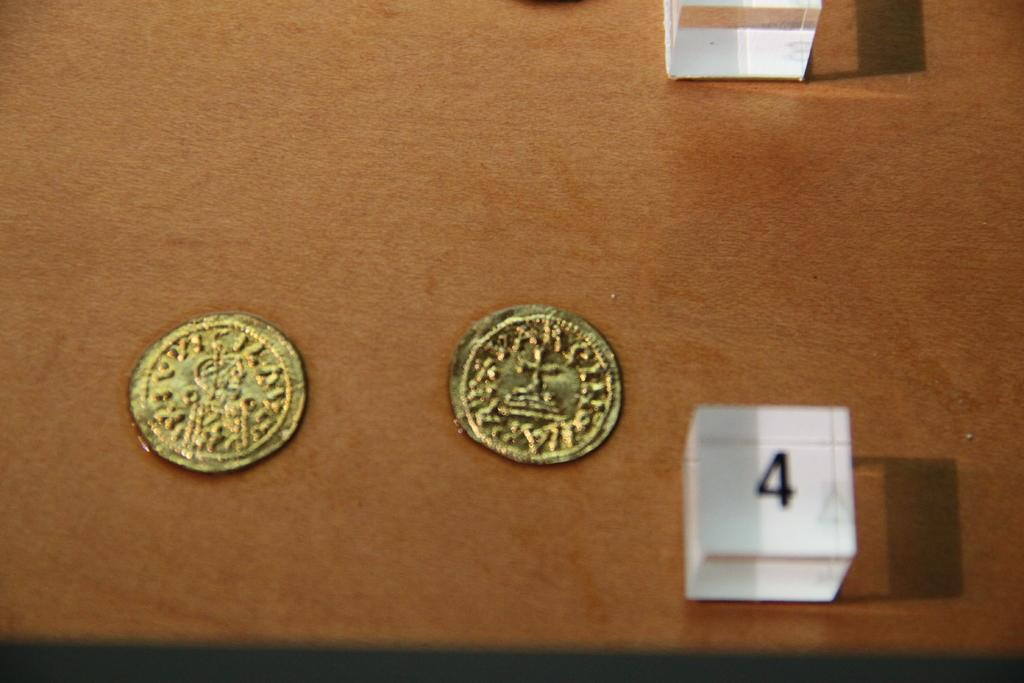<image>
Give a short and clear explanation of the subsequent image. A white box with a four on it is next to two gold coins. 